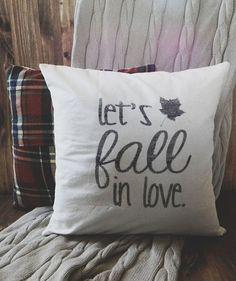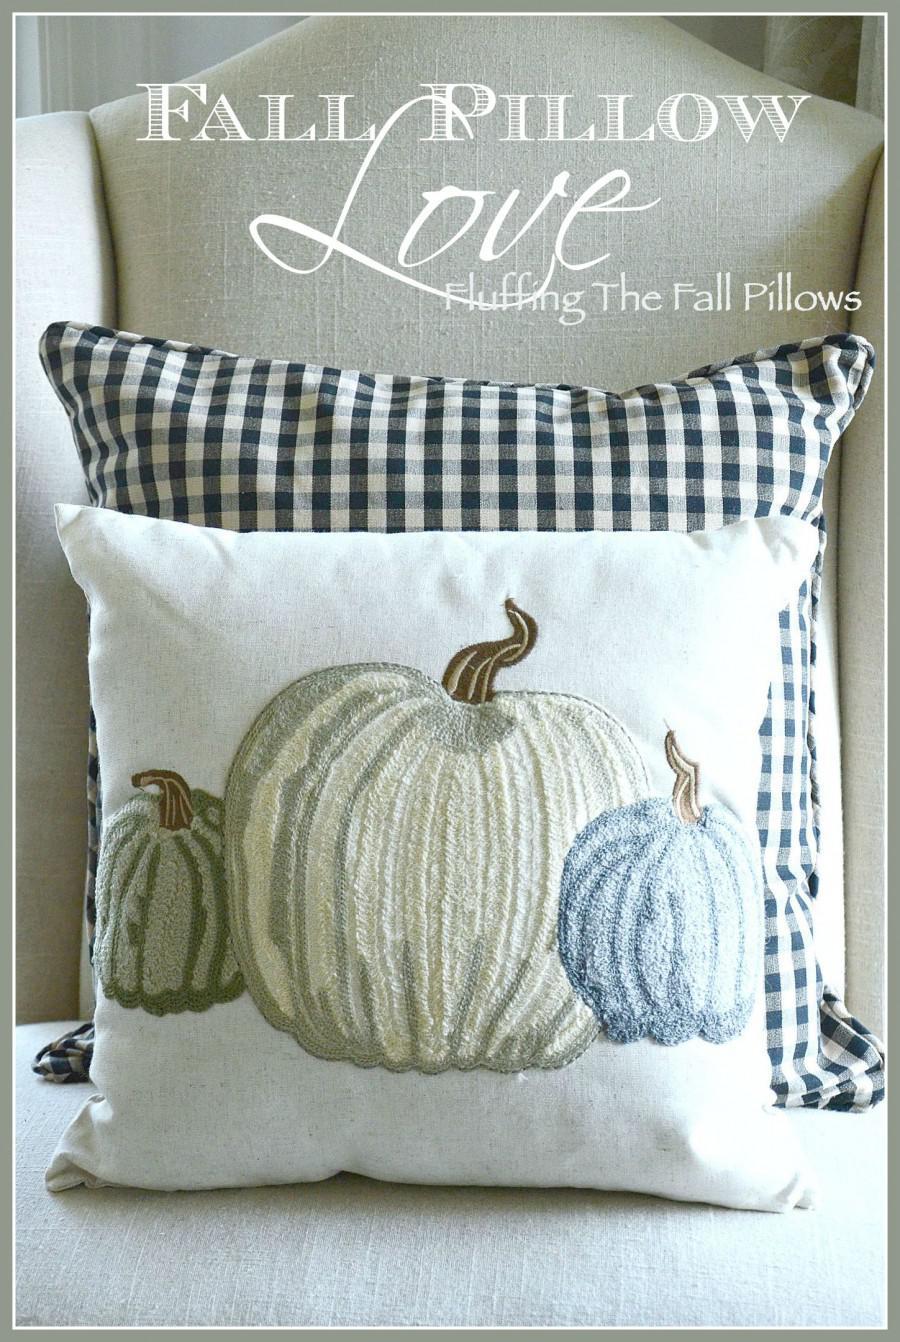The first image is the image on the left, the second image is the image on the right. Given the left and right images, does the statement "Two pillows with writing on them." hold true? Answer yes or no. No. The first image is the image on the left, the second image is the image on the right. Analyze the images presented: Is the assertion "There is at least one throw blanket under at least one pillow." valid? Answer yes or no. Yes. 